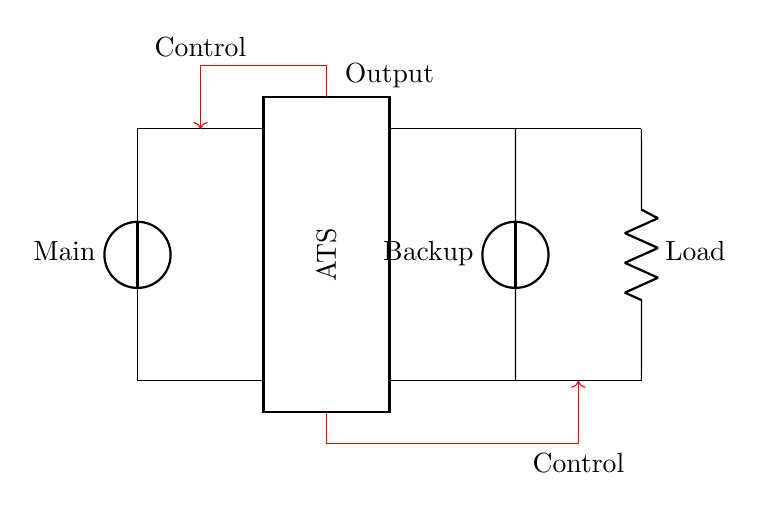What is the main power source in this circuit? The main power source is indicated as "Main" and is represented by the leftmost voltage source in the diagram.
Answer: Main What component controls the transfer between power sources? The part labeled "ATS" stands for Automatic Transfer Switch, which is the device responsible for switching between the main supply and the backup generator.
Answer: ATS How many voltage sources are shown in the circuit? There are two voltage sources depicted: one for the main power and one for the backup generator. Each source is represented by a distinct symbol and label in the circuit.
Answer: 2 What is the function of the control lines in the circuit? The control lines are drawn in red and show the connection from the ATS to control devices, indicating the operation of switching between the power sources based on availability.
Answer: Control Which component delivers power to the load? The "Load" connected to the circuit is powered through the connections from the ATS, using lines that extend from the upper part of the ATS to the load itself.
Answer: Load What is indicated by the arrows on the control lines? The arrows indicate the direction of control signals, which suggests that the control mechanism sends signals from the ATS to the load and vice versa to manage the power source transitions.
Answer: Direction of control What happens when the main power supply is unavailable? When the main power supply fails, the ATS automatically switches to the backup power supply, ensuring continuous operation of the load without interruption.
Answer: Backup power takes over 